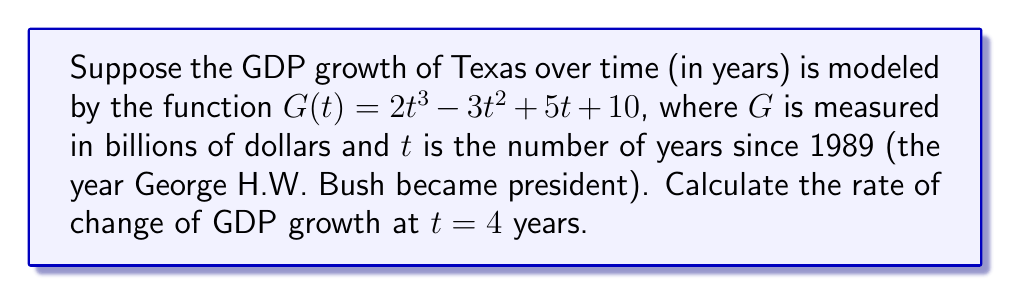Can you answer this question? To find the rate of change of GDP growth at $t = 4$, we need to:
1. Find the derivative of the function $G(t)$
2. Evaluate the derivative at $t = 4$

Step 1: Finding the derivative of $G(t)$
The function is $G(t) = 2t^3 - 3t^2 + 5t + 10$

Using the power rule and constant rule:
$$\frac{d}{dt}(2t^3) = 6t^2$$
$$\frac{d}{dt}(-3t^2) = -6t$$
$$\frac{d}{dt}(5t) = 5$$
$$\frac{d}{dt}(10) = 0$$

Combining these terms, we get:
$$G'(t) = 6t^2 - 6t + 5$$

Step 2: Evaluating $G'(t)$ at $t = 4$
$$G'(4) = 6(4)^2 - 6(4) + 5$$
$$= 6(16) - 24 + 5$$
$$= 96 - 24 + 5$$
$$= 77$$

Therefore, the rate of change of GDP growth at $t = 4$ years (i.e., in 1993) is 77 billion dollars per year.
Answer: $77$ billion dollars per year 